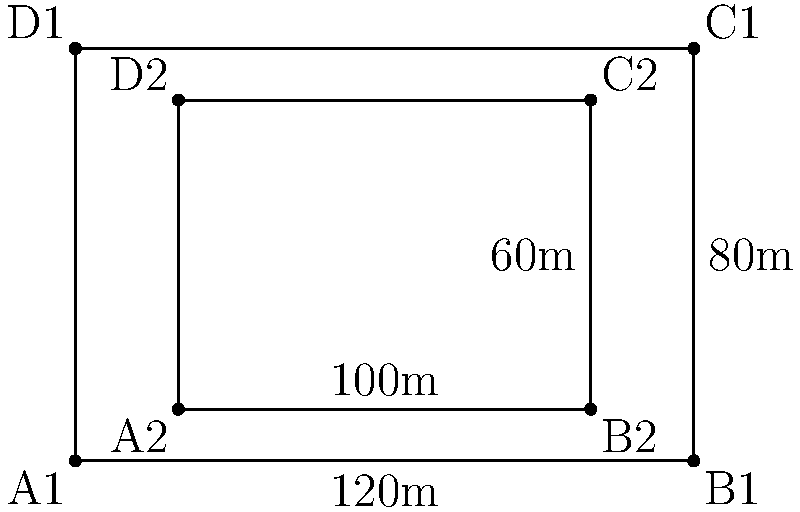As a football commentator and historian, you're comparing two iconic rectangular stadiums. The outer rectangle represents the larger stadium, while the inner rectangle represents the smaller one. The larger stadium measures 120m by 80m, and the smaller stadium is 100m by 60m. What is the difference in area between these two historic venues? Let's approach this step-by-step:

1) First, we need to calculate the area of the larger stadium:
   Area of larger stadium = length × width
   $A_1 = 120\text{m} \times 80\text{m} = 9600\text{m}^2$

2) Next, we calculate the area of the smaller stadium:
   Area of smaller stadium = length × width
   $A_2 = 100\text{m} \times 60\text{m} = 6000\text{m}^2$

3) Now, to find the difference in area, we subtract the area of the smaller stadium from the area of the larger stadium:
   Difference in area = $A_1 - A_2$
   $= 9600\text{m}^2 - 6000\text{m}^2 = 3600\text{m}^2$

Therefore, the difference in area between the two stadiums is 3600 square meters.
Answer: $3600\text{m}^2$ 